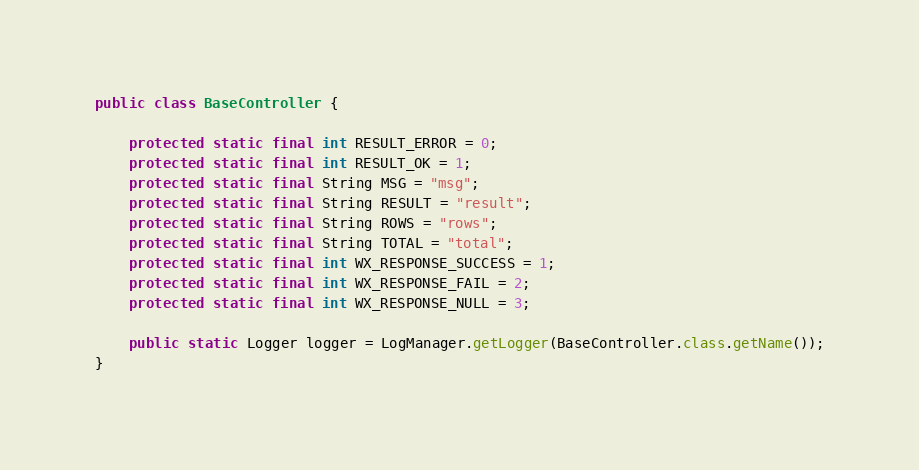<code> <loc_0><loc_0><loc_500><loc_500><_Java_>public class BaseController {
	
	protected static final int RESULT_ERROR = 0;
	protected static final int RESULT_OK = 1;
	protected static final String MSG = "msg";
	protected static final String RESULT = "result";
	protected static final String ROWS = "rows";
	protected static final String TOTAL = "total";
	protected static final int WX_RESPONSE_SUCCESS = 1;
	protected static final int WX_RESPONSE_FAIL = 2;
	protected static final int WX_RESPONSE_NULL = 3;
	
	public static Logger logger = LogManager.getLogger(BaseController.class.getName());
}
</code> 